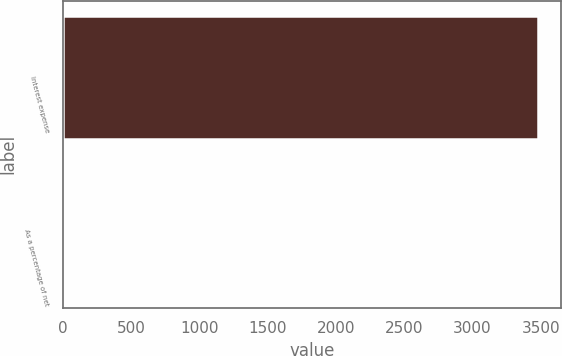Convert chart to OTSL. <chart><loc_0><loc_0><loc_500><loc_500><bar_chart><fcel>Interest expense<fcel>As a percentage of net<nl><fcel>3478<fcel>0.1<nl></chart> 